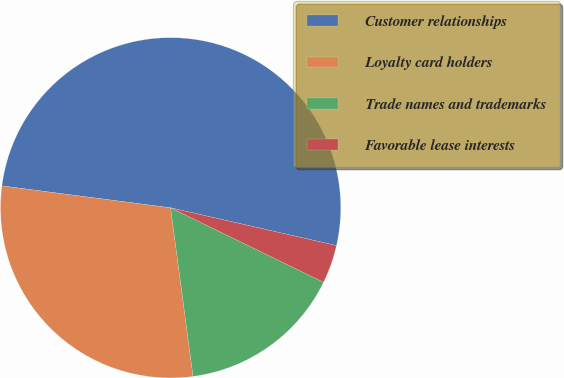<chart> <loc_0><loc_0><loc_500><loc_500><pie_chart><fcel>Customer relationships<fcel>Loyalty card holders<fcel>Trade names and trademarks<fcel>Favorable lease interests<nl><fcel>51.51%<fcel>29.16%<fcel>15.68%<fcel>3.65%<nl></chart> 